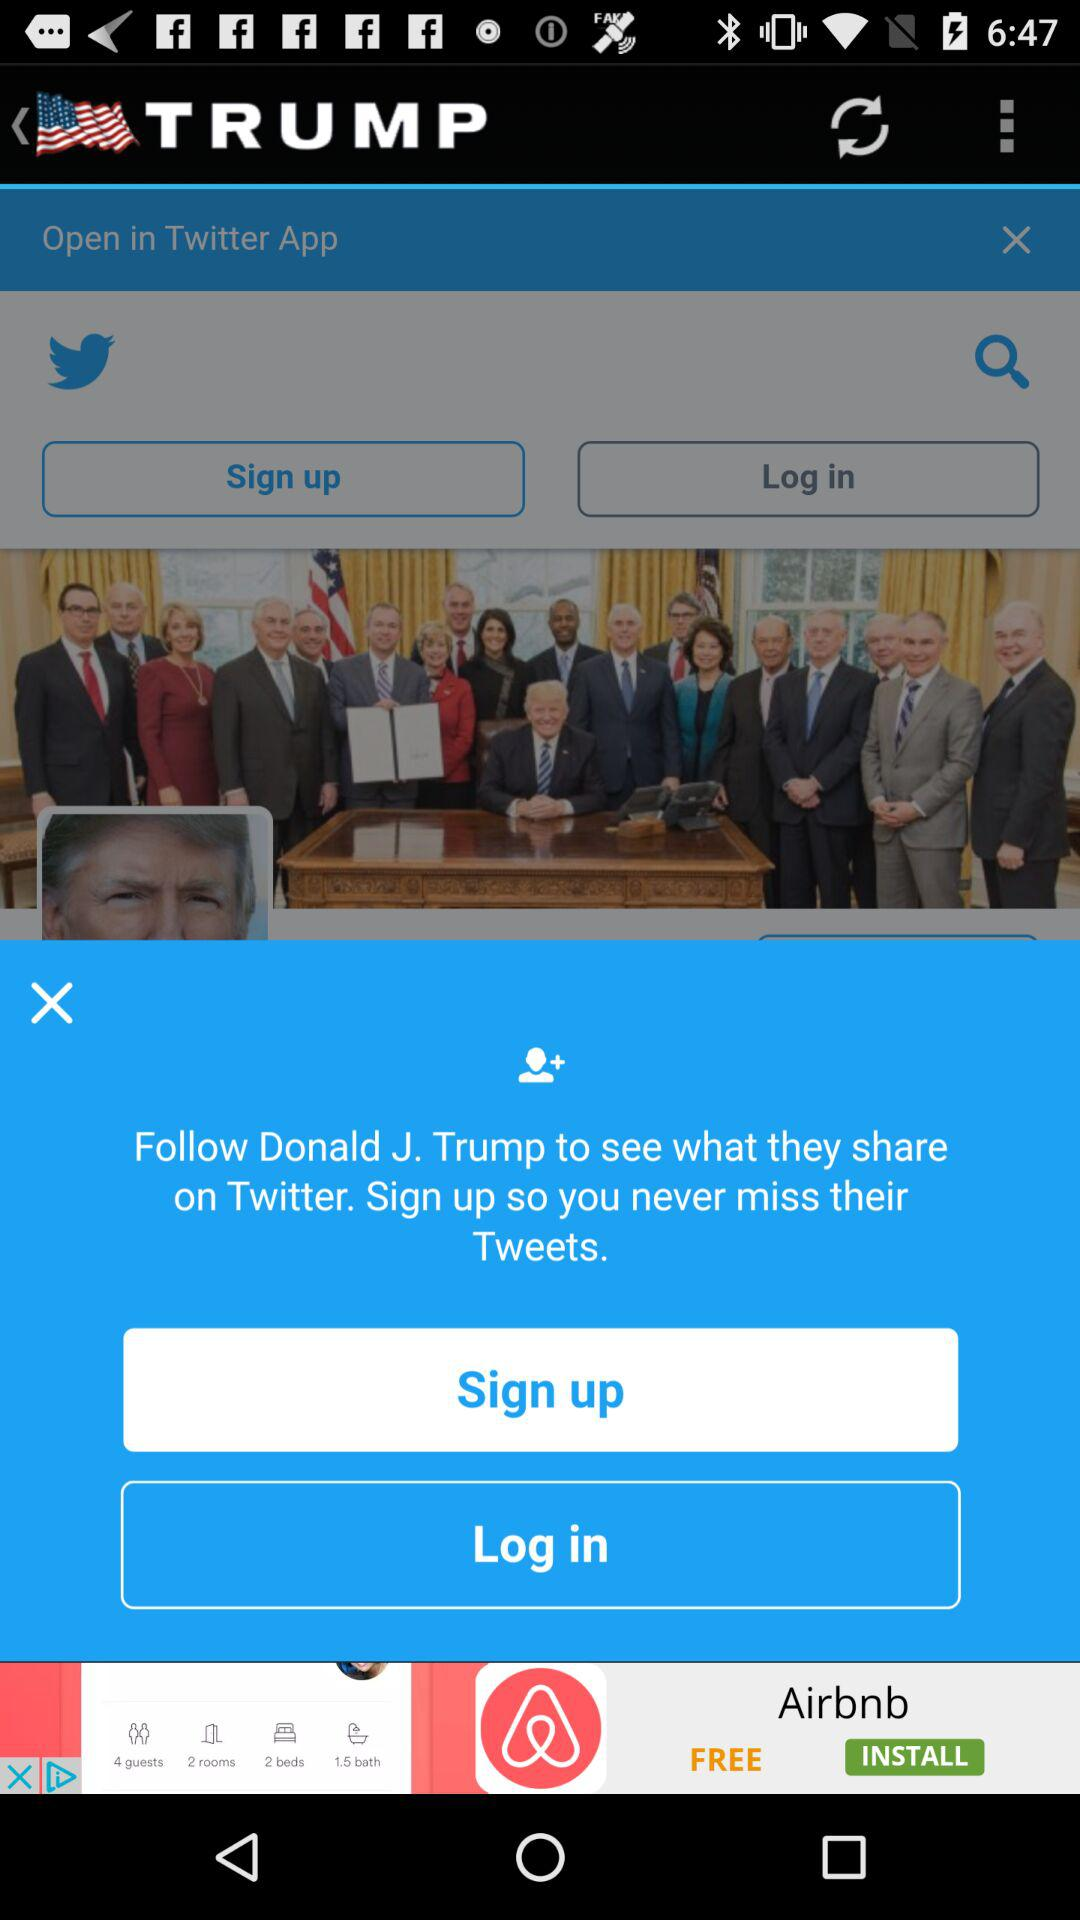Whom to follow to see what they share? We need to follow Donald J. Trump. 